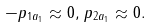<formula> <loc_0><loc_0><loc_500><loc_500>- p _ { 1 a _ { 1 } } \approx 0 , \, p _ { 2 a _ { 1 } } \approx 0 .</formula> 